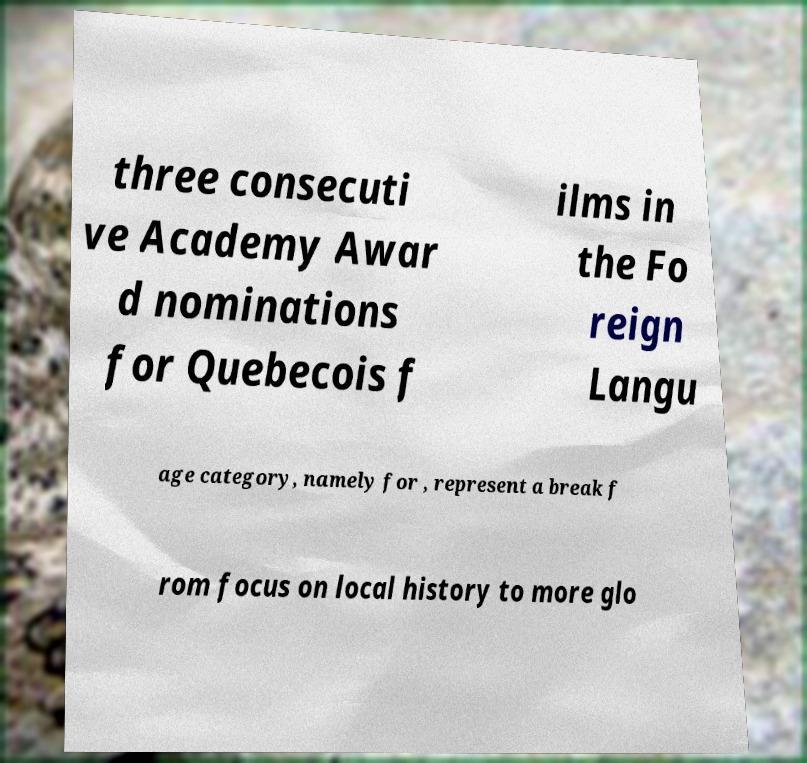Could you extract and type out the text from this image? three consecuti ve Academy Awar d nominations for Quebecois f ilms in the Fo reign Langu age category, namely for , represent a break f rom focus on local history to more glo 